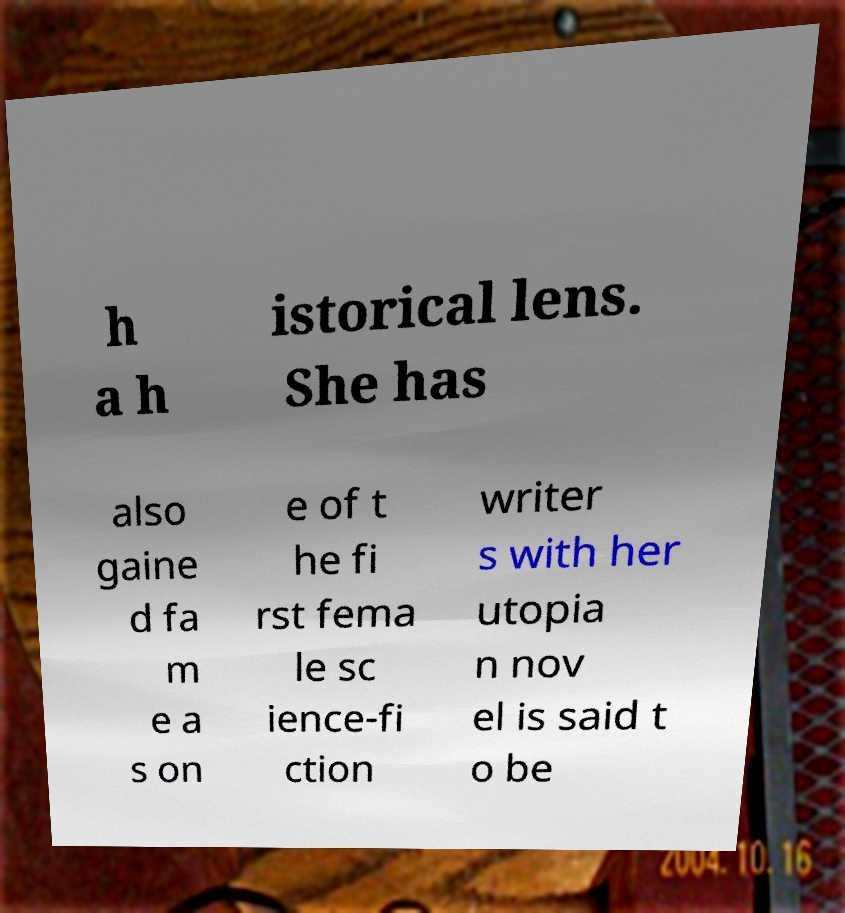Could you extract and type out the text from this image? h a h istorical lens. She has also gaine d fa m e a s on e of t he fi rst fema le sc ience-fi ction writer s with her utopia n nov el is said t o be 